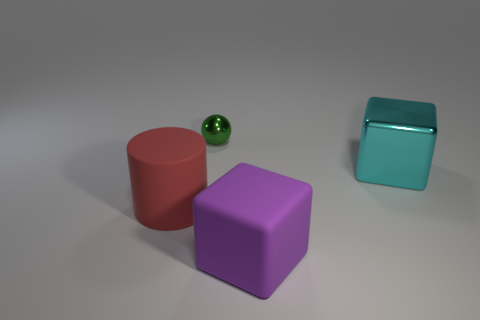There is a purple rubber thing that is the same shape as the cyan metal object; what size is it?
Provide a short and direct response. Large. Are there the same number of metallic balls that are in front of the small metal sphere and cyan things?
Ensure brevity in your answer.  No. There is a thing behind the cyan thing; does it have the same shape as the large cyan thing?
Make the answer very short. No. The big metal thing is what shape?
Keep it short and to the point. Cube. There is a red thing behind the large object in front of the big object that is on the left side of the purple matte thing; what is its material?
Your answer should be compact. Rubber. What number of objects are either tiny green spheres or purple things?
Make the answer very short. 2. Do the large thing behind the rubber cylinder and the cylinder have the same material?
Ensure brevity in your answer.  No. How many things are blocks in front of the big cyan metal object or big rubber spheres?
Give a very brief answer. 1. What is the color of the large thing that is the same material as the large cylinder?
Your response must be concise. Purple. Is there another ball that has the same size as the green sphere?
Give a very brief answer. No. 